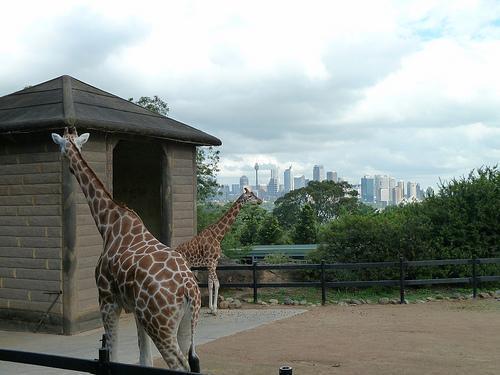How many animals?
Give a very brief answer. 2. 